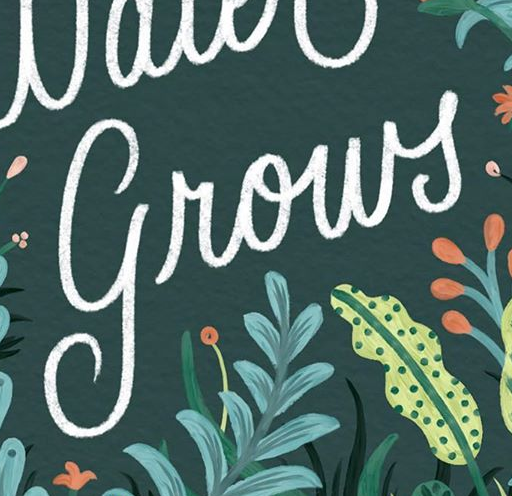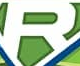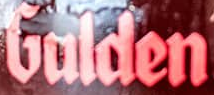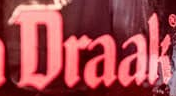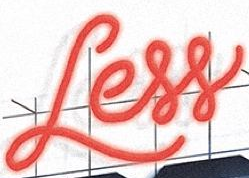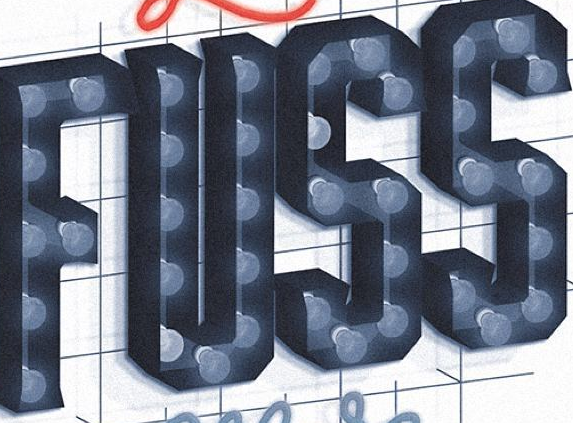What text appears in these images from left to right, separated by a semicolon? grows; R; Gulden; Draak; Less; FUSS 